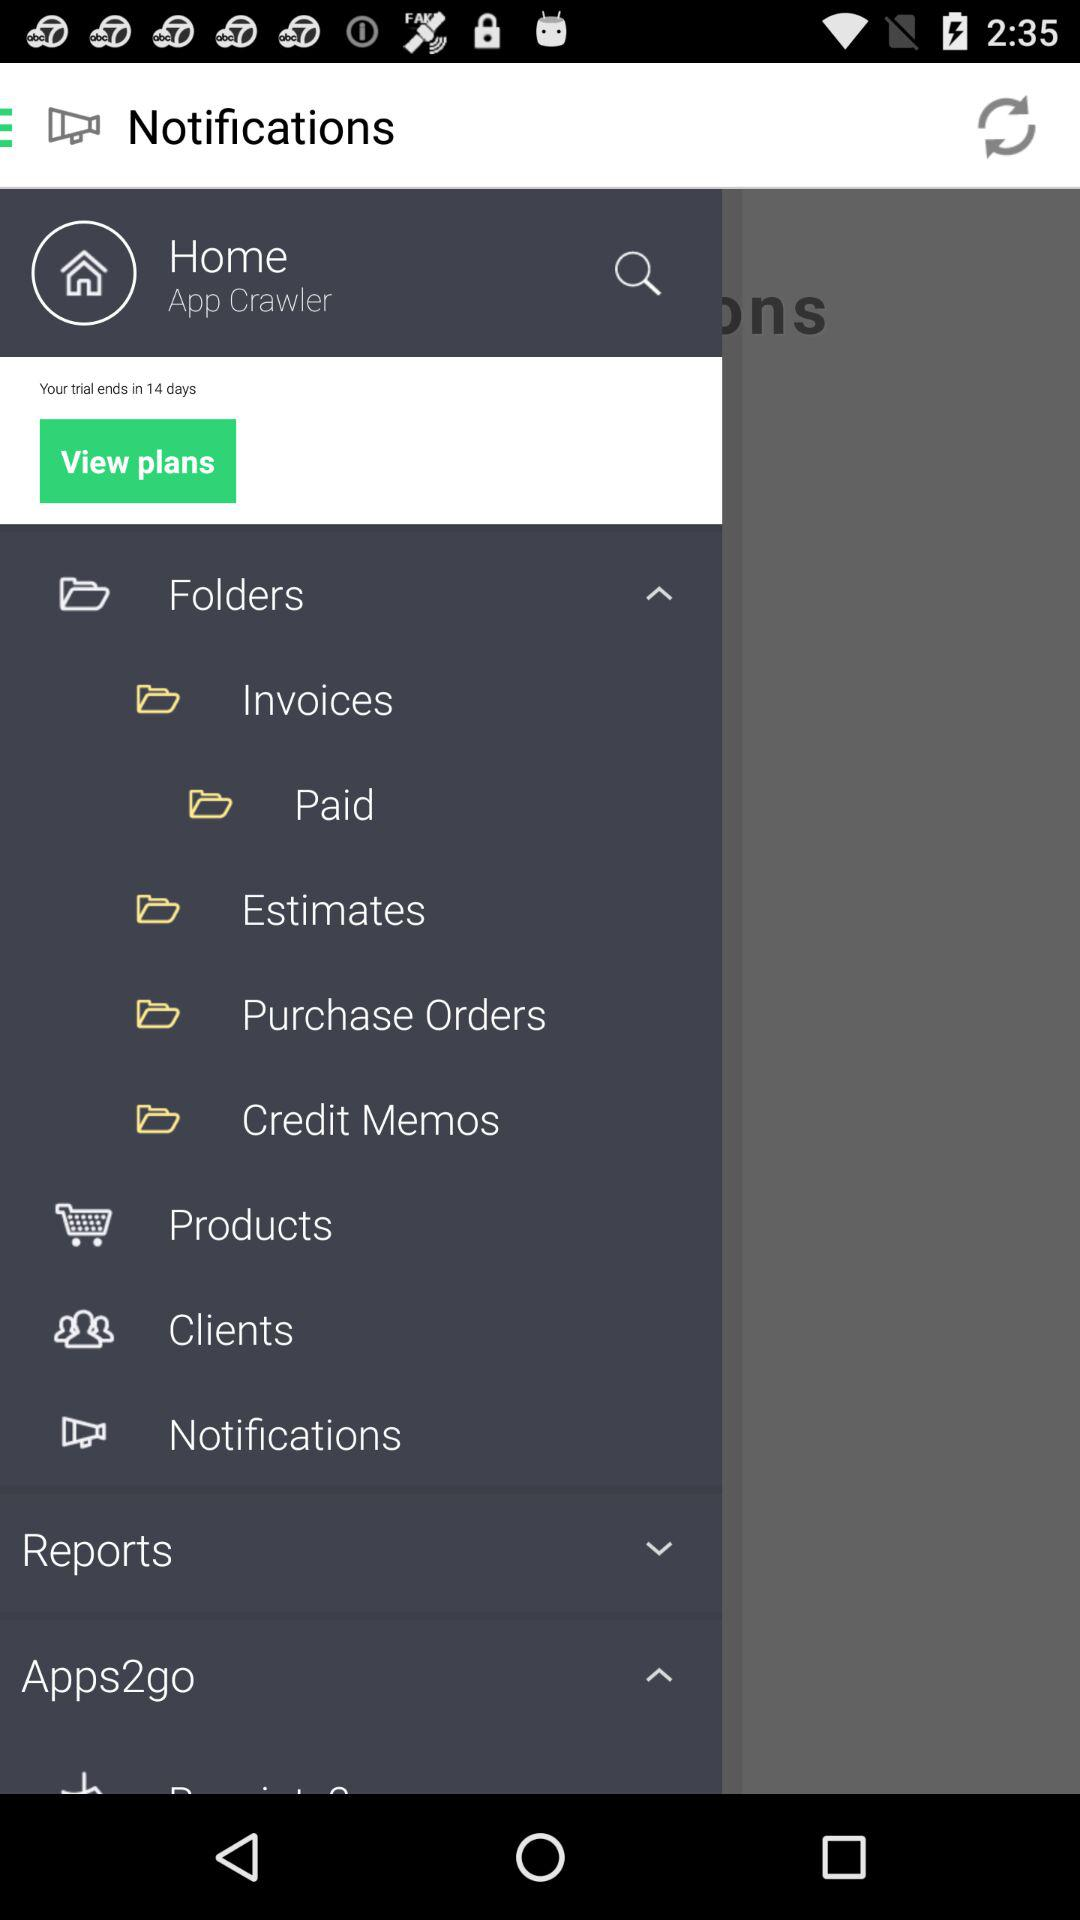What is the name of the user? The name of the user is App Crawler. 